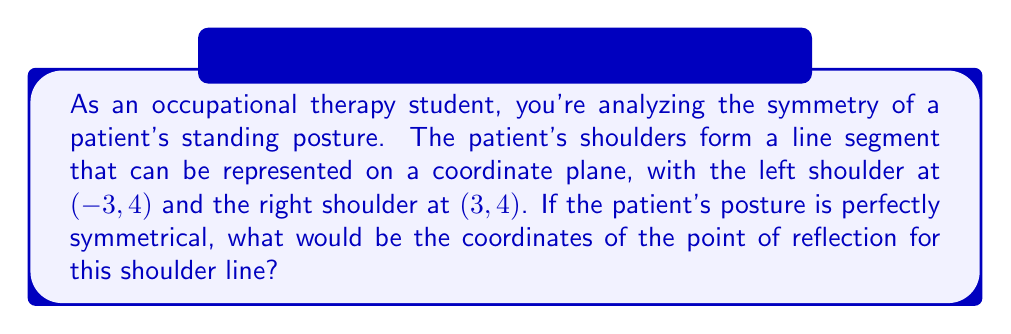Solve this math problem. Let's approach this step-by-step:

1) In a perfectly symmetrical posture, the point of reflection would be exactly in the middle of the line segment connecting the shoulders.

2) To find the midpoint of a line segment, we can use the midpoint formula:
   $$(x, y) = (\frac{x_1 + x_2}{2}, \frac{y_1 + y_2}{2})$$
   where $(x_1, y_1)$ and $(x_2, y_2)$ are the coordinates of the endpoints.

3) In this case:
   $(x_1, y_1) = (-3, 4)$ (left shoulder)
   $(x_2, y_2) = (3, 4)$ (right shoulder)

4) Let's calculate the x-coordinate of the midpoint:
   $$x = \frac{x_1 + x_2}{2} = \frac{-3 + 3}{2} = \frac{0}{2} = 0$$

5) Now, let's calculate the y-coordinate of the midpoint:
   $$y = \frac{y_1 + y_2}{2} = \frac{4 + 4}{2} = \frac{8}{2} = 4$$

6) Therefore, the point of reflection is at (0, 4).

This point represents the center of symmetry for the patient's shoulder line, and in a perfectly symmetrical posture, it would align with the center of the patient's body.
Answer: (0, 4) 